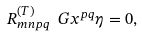Convert formula to latex. <formula><loc_0><loc_0><loc_500><loc_500>R ^ { ( T ) } _ { m n p q } \ G x ^ { p q } \eta = 0 ,</formula> 